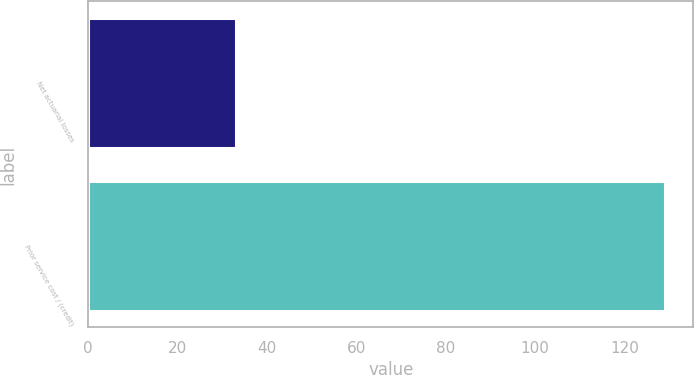Convert chart. <chart><loc_0><loc_0><loc_500><loc_500><bar_chart><fcel>Net actuarial losses<fcel>Prior service cost / (credit)<nl><fcel>33<fcel>129<nl></chart> 